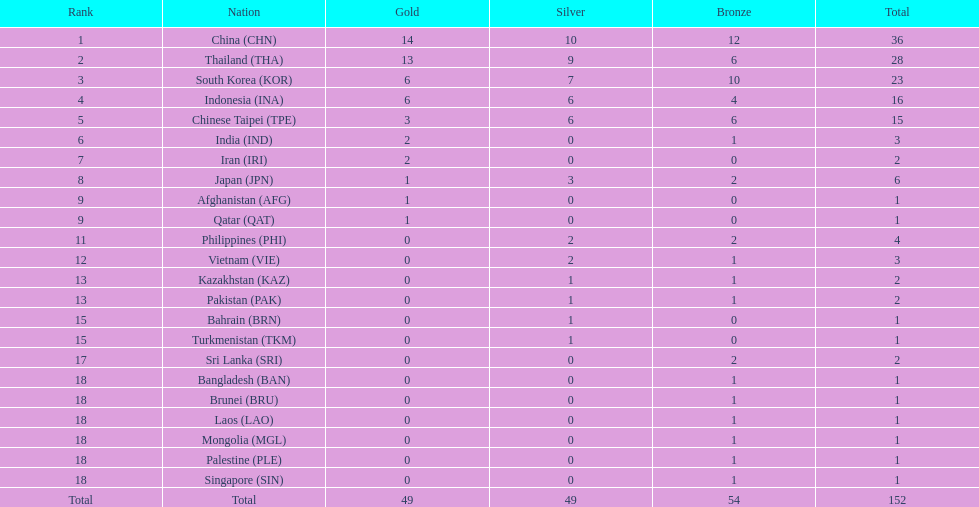Which nations secured the same quantity of gold medals as japan? Afghanistan (AFG), Qatar (QAT). 